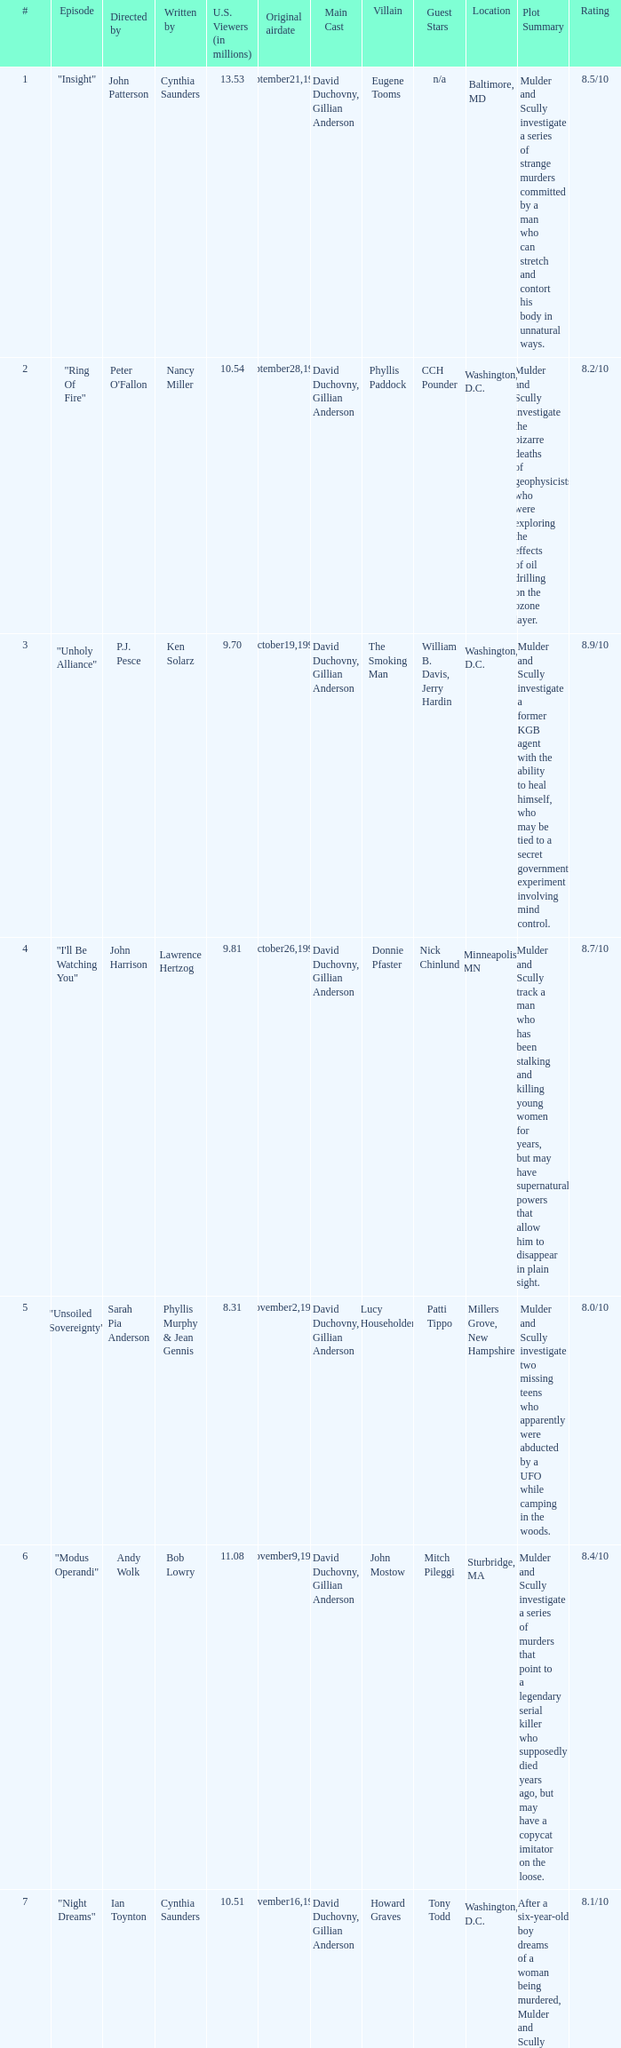Who wrote the episode with 7.52 million US viewers? George Geiger & Charles D. Holland. 